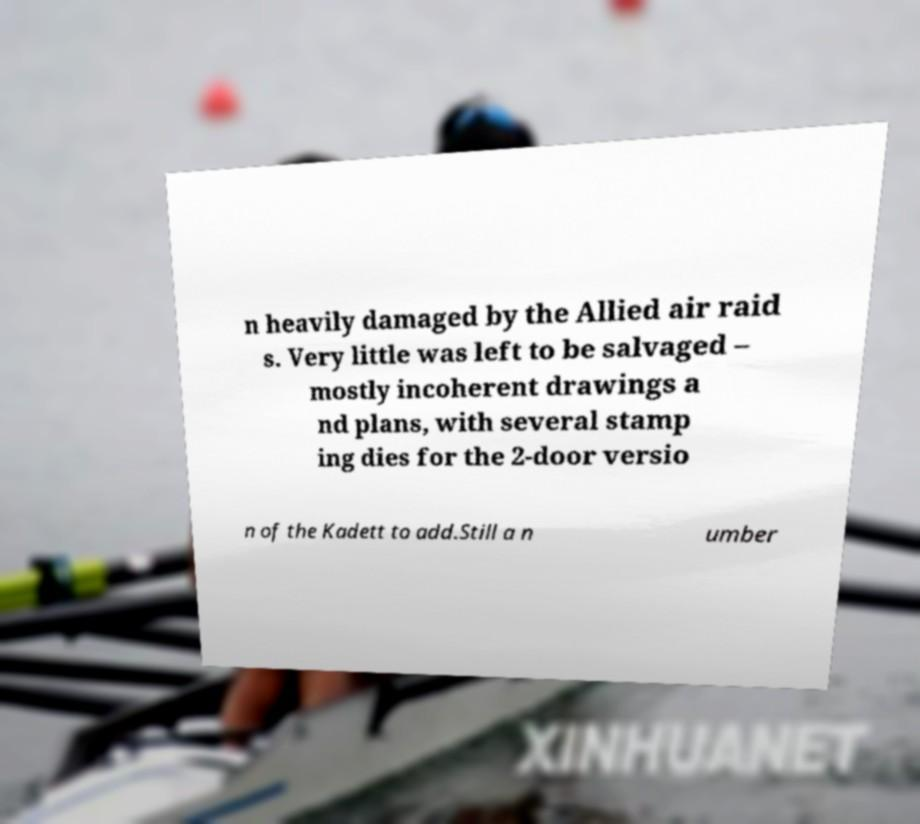For documentation purposes, I need the text within this image transcribed. Could you provide that? n heavily damaged by the Allied air raid s. Very little was left to be salvaged – mostly incoherent drawings a nd plans, with several stamp ing dies for the 2-door versio n of the Kadett to add.Still a n umber 